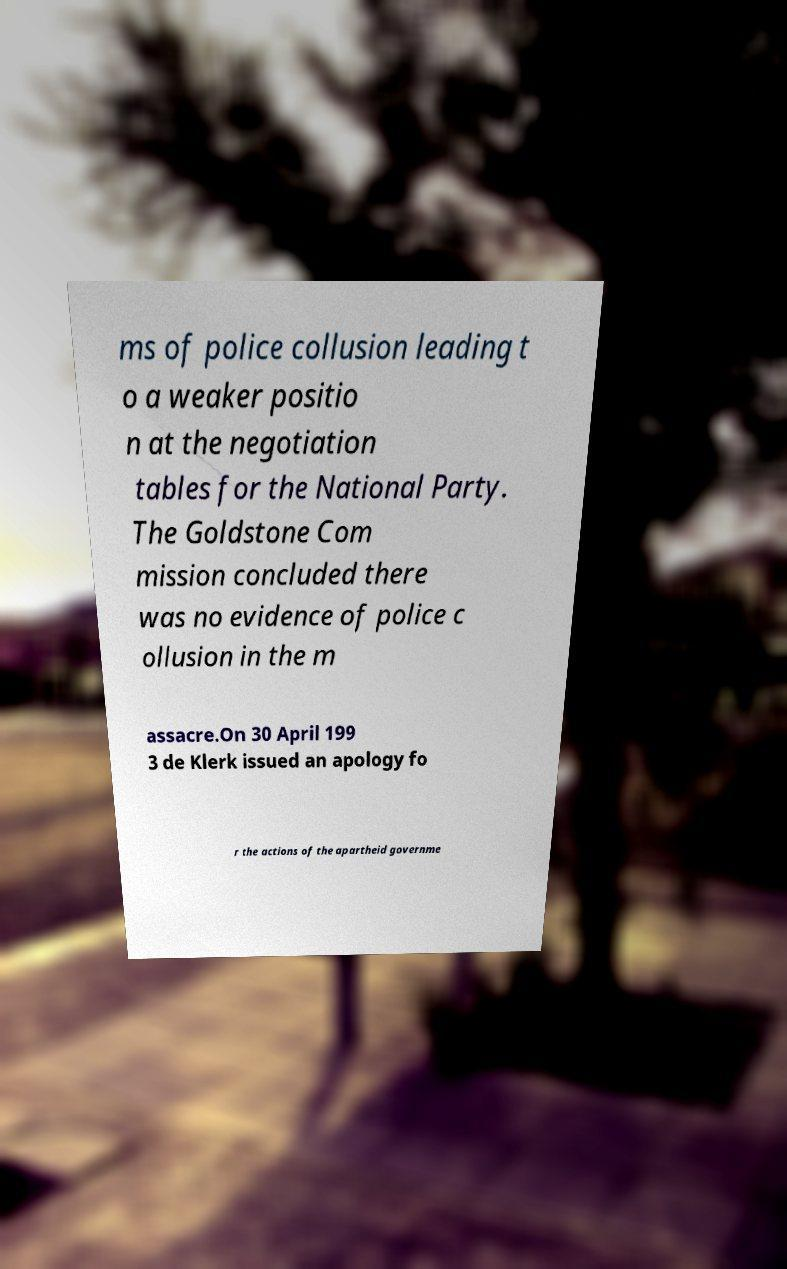Please identify and transcribe the text found in this image. ms of police collusion leading t o a weaker positio n at the negotiation tables for the National Party. The Goldstone Com mission concluded there was no evidence of police c ollusion in the m assacre.On 30 April 199 3 de Klerk issued an apology fo r the actions of the apartheid governme 